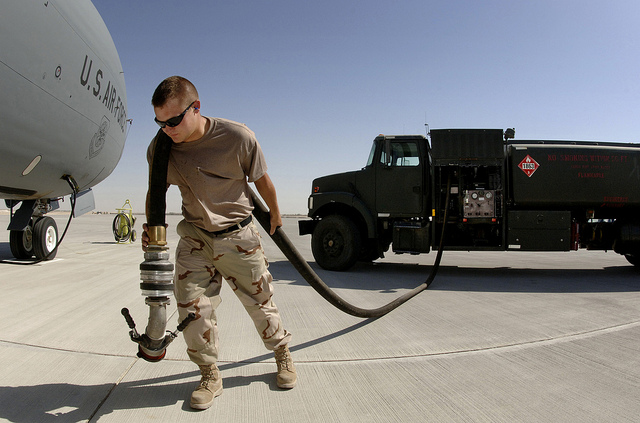Please transcribe the text in this image. U.S. AIR S.AIR AIR 